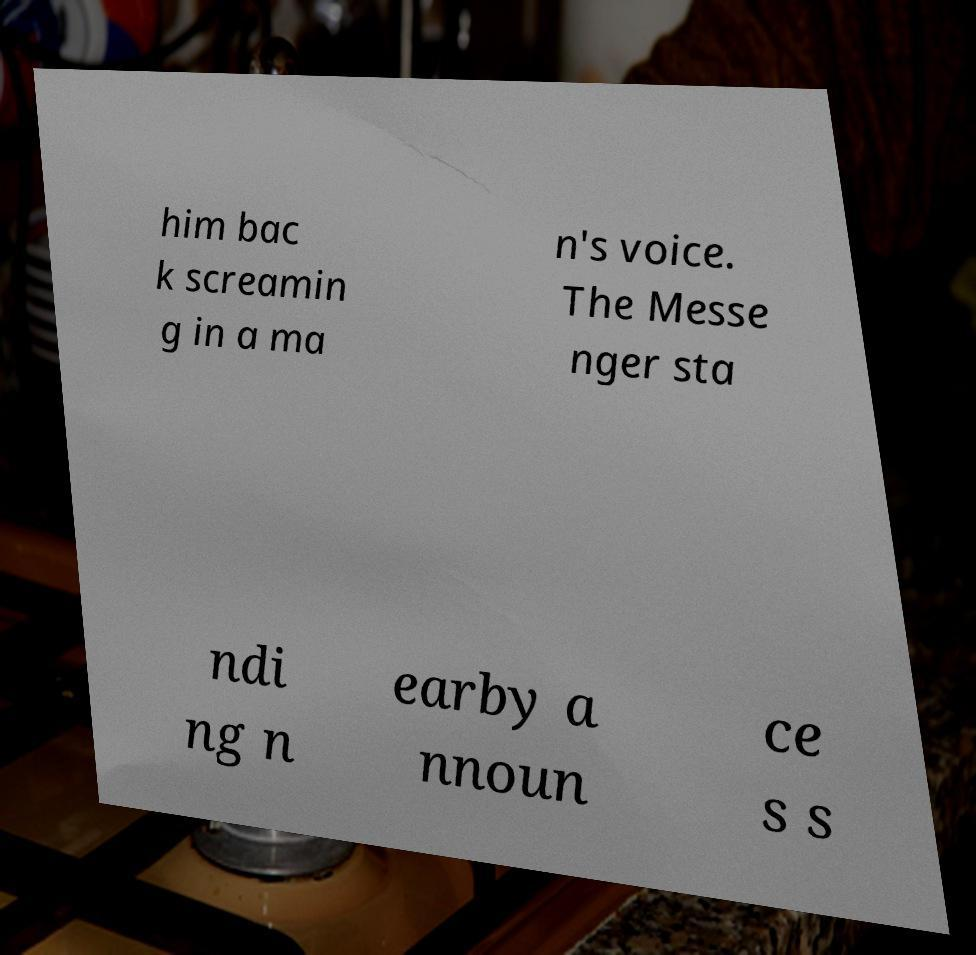I need the written content from this picture converted into text. Can you do that? him bac k screamin g in a ma n's voice. The Messe nger sta ndi ng n earby a nnoun ce s s 